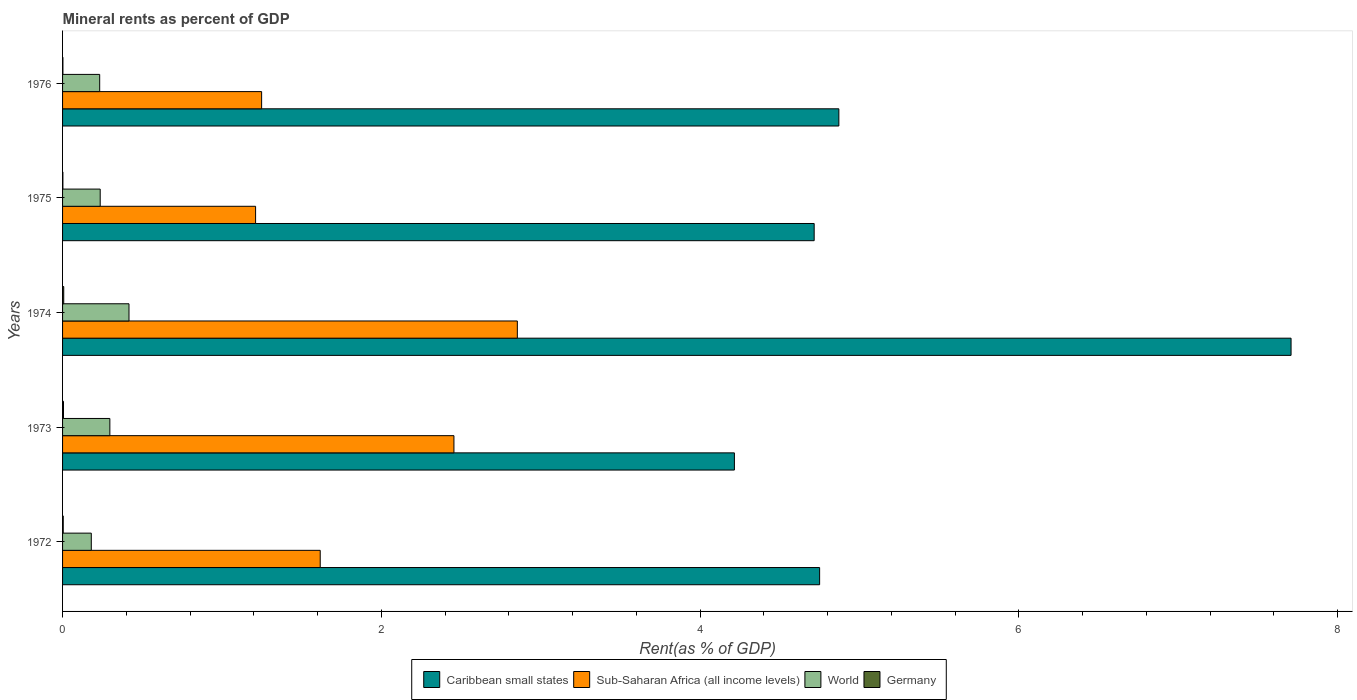How many different coloured bars are there?
Your answer should be compact. 4. How many groups of bars are there?
Your answer should be very brief. 5. Are the number of bars per tick equal to the number of legend labels?
Provide a succinct answer. Yes. Are the number of bars on each tick of the Y-axis equal?
Your answer should be compact. Yes. How many bars are there on the 2nd tick from the bottom?
Keep it short and to the point. 4. What is the label of the 4th group of bars from the top?
Keep it short and to the point. 1973. What is the mineral rent in Germany in 1973?
Ensure brevity in your answer.  0.01. Across all years, what is the maximum mineral rent in Sub-Saharan Africa (all income levels)?
Keep it short and to the point. 2.85. Across all years, what is the minimum mineral rent in Caribbean small states?
Give a very brief answer. 4.22. In which year was the mineral rent in World maximum?
Your response must be concise. 1974. In which year was the mineral rent in Sub-Saharan Africa (all income levels) minimum?
Your answer should be very brief. 1975. What is the total mineral rent in World in the graph?
Give a very brief answer. 1.36. What is the difference between the mineral rent in Caribbean small states in 1972 and that in 1975?
Provide a succinct answer. 0.03. What is the difference between the mineral rent in Germany in 1973 and the mineral rent in Caribbean small states in 1974?
Your answer should be compact. -7.7. What is the average mineral rent in World per year?
Your answer should be compact. 0.27. In the year 1972, what is the difference between the mineral rent in World and mineral rent in Caribbean small states?
Provide a short and direct response. -4.57. In how many years, is the mineral rent in Caribbean small states greater than 2 %?
Provide a short and direct response. 5. What is the ratio of the mineral rent in Germany in 1974 to that in 1975?
Provide a succinct answer. 3.67. Is the mineral rent in Germany in 1974 less than that in 1975?
Give a very brief answer. No. Is the difference between the mineral rent in World in 1972 and 1976 greater than the difference between the mineral rent in Caribbean small states in 1972 and 1976?
Provide a succinct answer. Yes. What is the difference between the highest and the second highest mineral rent in World?
Provide a succinct answer. 0.12. What is the difference between the highest and the lowest mineral rent in Germany?
Offer a terse response. 0.01. Is it the case that in every year, the sum of the mineral rent in Sub-Saharan Africa (all income levels) and mineral rent in World is greater than the sum of mineral rent in Germany and mineral rent in Caribbean small states?
Make the answer very short. No. Are all the bars in the graph horizontal?
Offer a terse response. Yes. How many years are there in the graph?
Your response must be concise. 5. What is the difference between two consecutive major ticks on the X-axis?
Keep it short and to the point. 2. Does the graph contain grids?
Keep it short and to the point. No. How many legend labels are there?
Your answer should be very brief. 4. What is the title of the graph?
Offer a terse response. Mineral rents as percent of GDP. Does "Low income" appear as one of the legend labels in the graph?
Ensure brevity in your answer.  No. What is the label or title of the X-axis?
Provide a short and direct response. Rent(as % of GDP). What is the label or title of the Y-axis?
Give a very brief answer. Years. What is the Rent(as % of GDP) of Caribbean small states in 1972?
Your response must be concise. 4.75. What is the Rent(as % of GDP) in Sub-Saharan Africa (all income levels) in 1972?
Make the answer very short. 1.62. What is the Rent(as % of GDP) in World in 1972?
Keep it short and to the point. 0.18. What is the Rent(as % of GDP) in Germany in 1972?
Your answer should be compact. 0. What is the Rent(as % of GDP) in Caribbean small states in 1973?
Give a very brief answer. 4.22. What is the Rent(as % of GDP) of Sub-Saharan Africa (all income levels) in 1973?
Offer a very short reply. 2.46. What is the Rent(as % of GDP) in World in 1973?
Ensure brevity in your answer.  0.3. What is the Rent(as % of GDP) of Germany in 1973?
Give a very brief answer. 0.01. What is the Rent(as % of GDP) of Caribbean small states in 1974?
Offer a very short reply. 7.71. What is the Rent(as % of GDP) of Sub-Saharan Africa (all income levels) in 1974?
Provide a short and direct response. 2.85. What is the Rent(as % of GDP) of World in 1974?
Keep it short and to the point. 0.42. What is the Rent(as % of GDP) in Germany in 1974?
Make the answer very short. 0.01. What is the Rent(as % of GDP) of Caribbean small states in 1975?
Your response must be concise. 4.72. What is the Rent(as % of GDP) in Sub-Saharan Africa (all income levels) in 1975?
Provide a short and direct response. 1.21. What is the Rent(as % of GDP) in World in 1975?
Your answer should be compact. 0.24. What is the Rent(as % of GDP) in Germany in 1975?
Offer a very short reply. 0. What is the Rent(as % of GDP) in Caribbean small states in 1976?
Give a very brief answer. 4.87. What is the Rent(as % of GDP) of Sub-Saharan Africa (all income levels) in 1976?
Your response must be concise. 1.25. What is the Rent(as % of GDP) of World in 1976?
Provide a succinct answer. 0.23. What is the Rent(as % of GDP) in Germany in 1976?
Ensure brevity in your answer.  0. Across all years, what is the maximum Rent(as % of GDP) of Caribbean small states?
Your answer should be compact. 7.71. Across all years, what is the maximum Rent(as % of GDP) of Sub-Saharan Africa (all income levels)?
Your answer should be compact. 2.85. Across all years, what is the maximum Rent(as % of GDP) of World?
Keep it short and to the point. 0.42. Across all years, what is the maximum Rent(as % of GDP) of Germany?
Your answer should be compact. 0.01. Across all years, what is the minimum Rent(as % of GDP) in Caribbean small states?
Ensure brevity in your answer.  4.22. Across all years, what is the minimum Rent(as % of GDP) in Sub-Saharan Africa (all income levels)?
Make the answer very short. 1.21. Across all years, what is the minimum Rent(as % of GDP) in World?
Offer a terse response. 0.18. Across all years, what is the minimum Rent(as % of GDP) of Germany?
Provide a short and direct response. 0. What is the total Rent(as % of GDP) of Caribbean small states in the graph?
Your answer should be very brief. 26.26. What is the total Rent(as % of GDP) of Sub-Saharan Africa (all income levels) in the graph?
Your answer should be very brief. 9.39. What is the total Rent(as % of GDP) of World in the graph?
Offer a very short reply. 1.36. What is the total Rent(as % of GDP) of Germany in the graph?
Offer a terse response. 0.02. What is the difference between the Rent(as % of GDP) in Caribbean small states in 1972 and that in 1973?
Offer a very short reply. 0.53. What is the difference between the Rent(as % of GDP) in Sub-Saharan Africa (all income levels) in 1972 and that in 1973?
Give a very brief answer. -0.84. What is the difference between the Rent(as % of GDP) of World in 1972 and that in 1973?
Ensure brevity in your answer.  -0.12. What is the difference between the Rent(as % of GDP) in Germany in 1972 and that in 1973?
Your response must be concise. -0. What is the difference between the Rent(as % of GDP) of Caribbean small states in 1972 and that in 1974?
Keep it short and to the point. -2.96. What is the difference between the Rent(as % of GDP) in Sub-Saharan Africa (all income levels) in 1972 and that in 1974?
Your answer should be very brief. -1.24. What is the difference between the Rent(as % of GDP) of World in 1972 and that in 1974?
Ensure brevity in your answer.  -0.24. What is the difference between the Rent(as % of GDP) of Germany in 1972 and that in 1974?
Offer a very short reply. -0. What is the difference between the Rent(as % of GDP) in Caribbean small states in 1972 and that in 1975?
Offer a very short reply. 0.03. What is the difference between the Rent(as % of GDP) of Sub-Saharan Africa (all income levels) in 1972 and that in 1975?
Your answer should be compact. 0.41. What is the difference between the Rent(as % of GDP) in World in 1972 and that in 1975?
Offer a terse response. -0.06. What is the difference between the Rent(as % of GDP) of Germany in 1972 and that in 1975?
Your answer should be compact. 0. What is the difference between the Rent(as % of GDP) of Caribbean small states in 1972 and that in 1976?
Provide a succinct answer. -0.12. What is the difference between the Rent(as % of GDP) of Sub-Saharan Africa (all income levels) in 1972 and that in 1976?
Make the answer very short. 0.37. What is the difference between the Rent(as % of GDP) of World in 1972 and that in 1976?
Your answer should be compact. -0.05. What is the difference between the Rent(as % of GDP) in Germany in 1972 and that in 1976?
Your response must be concise. 0. What is the difference between the Rent(as % of GDP) of Caribbean small states in 1973 and that in 1974?
Offer a very short reply. -3.49. What is the difference between the Rent(as % of GDP) of Sub-Saharan Africa (all income levels) in 1973 and that in 1974?
Your answer should be compact. -0.4. What is the difference between the Rent(as % of GDP) of World in 1973 and that in 1974?
Make the answer very short. -0.12. What is the difference between the Rent(as % of GDP) in Germany in 1973 and that in 1974?
Give a very brief answer. -0. What is the difference between the Rent(as % of GDP) in Caribbean small states in 1973 and that in 1975?
Your answer should be very brief. -0.5. What is the difference between the Rent(as % of GDP) of Sub-Saharan Africa (all income levels) in 1973 and that in 1975?
Your answer should be very brief. 1.24. What is the difference between the Rent(as % of GDP) of World in 1973 and that in 1975?
Provide a short and direct response. 0.06. What is the difference between the Rent(as % of GDP) of Germany in 1973 and that in 1975?
Provide a succinct answer. 0. What is the difference between the Rent(as % of GDP) in Caribbean small states in 1973 and that in 1976?
Your response must be concise. -0.66. What is the difference between the Rent(as % of GDP) of Sub-Saharan Africa (all income levels) in 1973 and that in 1976?
Offer a terse response. 1.21. What is the difference between the Rent(as % of GDP) of World in 1973 and that in 1976?
Give a very brief answer. 0.06. What is the difference between the Rent(as % of GDP) of Germany in 1973 and that in 1976?
Offer a very short reply. 0. What is the difference between the Rent(as % of GDP) of Caribbean small states in 1974 and that in 1975?
Provide a short and direct response. 2.99. What is the difference between the Rent(as % of GDP) in Sub-Saharan Africa (all income levels) in 1974 and that in 1975?
Your answer should be very brief. 1.64. What is the difference between the Rent(as % of GDP) of World in 1974 and that in 1975?
Your answer should be compact. 0.18. What is the difference between the Rent(as % of GDP) of Germany in 1974 and that in 1975?
Ensure brevity in your answer.  0.01. What is the difference between the Rent(as % of GDP) in Caribbean small states in 1974 and that in 1976?
Offer a very short reply. 2.84. What is the difference between the Rent(as % of GDP) of Sub-Saharan Africa (all income levels) in 1974 and that in 1976?
Your answer should be compact. 1.6. What is the difference between the Rent(as % of GDP) in World in 1974 and that in 1976?
Your answer should be very brief. 0.18. What is the difference between the Rent(as % of GDP) of Germany in 1974 and that in 1976?
Your response must be concise. 0.01. What is the difference between the Rent(as % of GDP) in Caribbean small states in 1975 and that in 1976?
Your answer should be compact. -0.15. What is the difference between the Rent(as % of GDP) of Sub-Saharan Africa (all income levels) in 1975 and that in 1976?
Your response must be concise. -0.04. What is the difference between the Rent(as % of GDP) in World in 1975 and that in 1976?
Make the answer very short. 0. What is the difference between the Rent(as % of GDP) of Germany in 1975 and that in 1976?
Provide a short and direct response. -0. What is the difference between the Rent(as % of GDP) in Caribbean small states in 1972 and the Rent(as % of GDP) in Sub-Saharan Africa (all income levels) in 1973?
Provide a succinct answer. 2.29. What is the difference between the Rent(as % of GDP) in Caribbean small states in 1972 and the Rent(as % of GDP) in World in 1973?
Provide a short and direct response. 4.45. What is the difference between the Rent(as % of GDP) of Caribbean small states in 1972 and the Rent(as % of GDP) of Germany in 1973?
Offer a very short reply. 4.74. What is the difference between the Rent(as % of GDP) in Sub-Saharan Africa (all income levels) in 1972 and the Rent(as % of GDP) in World in 1973?
Your answer should be compact. 1.32. What is the difference between the Rent(as % of GDP) of Sub-Saharan Africa (all income levels) in 1972 and the Rent(as % of GDP) of Germany in 1973?
Provide a succinct answer. 1.61. What is the difference between the Rent(as % of GDP) of World in 1972 and the Rent(as % of GDP) of Germany in 1973?
Your answer should be very brief. 0.17. What is the difference between the Rent(as % of GDP) in Caribbean small states in 1972 and the Rent(as % of GDP) in Sub-Saharan Africa (all income levels) in 1974?
Make the answer very short. 1.9. What is the difference between the Rent(as % of GDP) of Caribbean small states in 1972 and the Rent(as % of GDP) of World in 1974?
Ensure brevity in your answer.  4.33. What is the difference between the Rent(as % of GDP) of Caribbean small states in 1972 and the Rent(as % of GDP) of Germany in 1974?
Keep it short and to the point. 4.74. What is the difference between the Rent(as % of GDP) of Sub-Saharan Africa (all income levels) in 1972 and the Rent(as % of GDP) of World in 1974?
Ensure brevity in your answer.  1.2. What is the difference between the Rent(as % of GDP) of Sub-Saharan Africa (all income levels) in 1972 and the Rent(as % of GDP) of Germany in 1974?
Offer a very short reply. 1.61. What is the difference between the Rent(as % of GDP) of World in 1972 and the Rent(as % of GDP) of Germany in 1974?
Offer a terse response. 0.17. What is the difference between the Rent(as % of GDP) in Caribbean small states in 1972 and the Rent(as % of GDP) in Sub-Saharan Africa (all income levels) in 1975?
Ensure brevity in your answer.  3.54. What is the difference between the Rent(as % of GDP) in Caribbean small states in 1972 and the Rent(as % of GDP) in World in 1975?
Ensure brevity in your answer.  4.51. What is the difference between the Rent(as % of GDP) in Caribbean small states in 1972 and the Rent(as % of GDP) in Germany in 1975?
Give a very brief answer. 4.75. What is the difference between the Rent(as % of GDP) of Sub-Saharan Africa (all income levels) in 1972 and the Rent(as % of GDP) of World in 1975?
Give a very brief answer. 1.38. What is the difference between the Rent(as % of GDP) in Sub-Saharan Africa (all income levels) in 1972 and the Rent(as % of GDP) in Germany in 1975?
Provide a succinct answer. 1.61. What is the difference between the Rent(as % of GDP) of World in 1972 and the Rent(as % of GDP) of Germany in 1975?
Give a very brief answer. 0.18. What is the difference between the Rent(as % of GDP) of Caribbean small states in 1972 and the Rent(as % of GDP) of Sub-Saharan Africa (all income levels) in 1976?
Offer a terse response. 3.5. What is the difference between the Rent(as % of GDP) of Caribbean small states in 1972 and the Rent(as % of GDP) of World in 1976?
Your response must be concise. 4.52. What is the difference between the Rent(as % of GDP) in Caribbean small states in 1972 and the Rent(as % of GDP) in Germany in 1976?
Your answer should be compact. 4.75. What is the difference between the Rent(as % of GDP) in Sub-Saharan Africa (all income levels) in 1972 and the Rent(as % of GDP) in World in 1976?
Ensure brevity in your answer.  1.38. What is the difference between the Rent(as % of GDP) in Sub-Saharan Africa (all income levels) in 1972 and the Rent(as % of GDP) in Germany in 1976?
Your response must be concise. 1.61. What is the difference between the Rent(as % of GDP) in World in 1972 and the Rent(as % of GDP) in Germany in 1976?
Provide a succinct answer. 0.18. What is the difference between the Rent(as % of GDP) in Caribbean small states in 1973 and the Rent(as % of GDP) in Sub-Saharan Africa (all income levels) in 1974?
Provide a short and direct response. 1.36. What is the difference between the Rent(as % of GDP) of Caribbean small states in 1973 and the Rent(as % of GDP) of World in 1974?
Make the answer very short. 3.8. What is the difference between the Rent(as % of GDP) of Caribbean small states in 1973 and the Rent(as % of GDP) of Germany in 1974?
Provide a succinct answer. 4.21. What is the difference between the Rent(as % of GDP) of Sub-Saharan Africa (all income levels) in 1973 and the Rent(as % of GDP) of World in 1974?
Offer a very short reply. 2.04. What is the difference between the Rent(as % of GDP) of Sub-Saharan Africa (all income levels) in 1973 and the Rent(as % of GDP) of Germany in 1974?
Make the answer very short. 2.45. What is the difference between the Rent(as % of GDP) in World in 1973 and the Rent(as % of GDP) in Germany in 1974?
Your answer should be very brief. 0.29. What is the difference between the Rent(as % of GDP) in Caribbean small states in 1973 and the Rent(as % of GDP) in Sub-Saharan Africa (all income levels) in 1975?
Your answer should be very brief. 3. What is the difference between the Rent(as % of GDP) of Caribbean small states in 1973 and the Rent(as % of GDP) of World in 1975?
Ensure brevity in your answer.  3.98. What is the difference between the Rent(as % of GDP) in Caribbean small states in 1973 and the Rent(as % of GDP) in Germany in 1975?
Give a very brief answer. 4.21. What is the difference between the Rent(as % of GDP) in Sub-Saharan Africa (all income levels) in 1973 and the Rent(as % of GDP) in World in 1975?
Offer a very short reply. 2.22. What is the difference between the Rent(as % of GDP) in Sub-Saharan Africa (all income levels) in 1973 and the Rent(as % of GDP) in Germany in 1975?
Make the answer very short. 2.45. What is the difference between the Rent(as % of GDP) in World in 1973 and the Rent(as % of GDP) in Germany in 1975?
Make the answer very short. 0.29. What is the difference between the Rent(as % of GDP) of Caribbean small states in 1973 and the Rent(as % of GDP) of Sub-Saharan Africa (all income levels) in 1976?
Make the answer very short. 2.97. What is the difference between the Rent(as % of GDP) of Caribbean small states in 1973 and the Rent(as % of GDP) of World in 1976?
Offer a very short reply. 3.98. What is the difference between the Rent(as % of GDP) in Caribbean small states in 1973 and the Rent(as % of GDP) in Germany in 1976?
Give a very brief answer. 4.21. What is the difference between the Rent(as % of GDP) of Sub-Saharan Africa (all income levels) in 1973 and the Rent(as % of GDP) of World in 1976?
Make the answer very short. 2.22. What is the difference between the Rent(as % of GDP) of Sub-Saharan Africa (all income levels) in 1973 and the Rent(as % of GDP) of Germany in 1976?
Offer a very short reply. 2.45. What is the difference between the Rent(as % of GDP) of World in 1973 and the Rent(as % of GDP) of Germany in 1976?
Offer a very short reply. 0.29. What is the difference between the Rent(as % of GDP) in Caribbean small states in 1974 and the Rent(as % of GDP) in Sub-Saharan Africa (all income levels) in 1975?
Your answer should be very brief. 6.5. What is the difference between the Rent(as % of GDP) of Caribbean small states in 1974 and the Rent(as % of GDP) of World in 1975?
Your answer should be very brief. 7.47. What is the difference between the Rent(as % of GDP) of Caribbean small states in 1974 and the Rent(as % of GDP) of Germany in 1975?
Your answer should be compact. 7.71. What is the difference between the Rent(as % of GDP) of Sub-Saharan Africa (all income levels) in 1974 and the Rent(as % of GDP) of World in 1975?
Provide a succinct answer. 2.62. What is the difference between the Rent(as % of GDP) in Sub-Saharan Africa (all income levels) in 1974 and the Rent(as % of GDP) in Germany in 1975?
Make the answer very short. 2.85. What is the difference between the Rent(as % of GDP) in World in 1974 and the Rent(as % of GDP) in Germany in 1975?
Make the answer very short. 0.41. What is the difference between the Rent(as % of GDP) of Caribbean small states in 1974 and the Rent(as % of GDP) of Sub-Saharan Africa (all income levels) in 1976?
Your response must be concise. 6.46. What is the difference between the Rent(as % of GDP) of Caribbean small states in 1974 and the Rent(as % of GDP) of World in 1976?
Your response must be concise. 7.48. What is the difference between the Rent(as % of GDP) in Caribbean small states in 1974 and the Rent(as % of GDP) in Germany in 1976?
Your answer should be very brief. 7.71. What is the difference between the Rent(as % of GDP) of Sub-Saharan Africa (all income levels) in 1974 and the Rent(as % of GDP) of World in 1976?
Give a very brief answer. 2.62. What is the difference between the Rent(as % of GDP) of Sub-Saharan Africa (all income levels) in 1974 and the Rent(as % of GDP) of Germany in 1976?
Give a very brief answer. 2.85. What is the difference between the Rent(as % of GDP) of World in 1974 and the Rent(as % of GDP) of Germany in 1976?
Your answer should be compact. 0.41. What is the difference between the Rent(as % of GDP) of Caribbean small states in 1975 and the Rent(as % of GDP) of Sub-Saharan Africa (all income levels) in 1976?
Provide a succinct answer. 3.47. What is the difference between the Rent(as % of GDP) in Caribbean small states in 1975 and the Rent(as % of GDP) in World in 1976?
Make the answer very short. 4.48. What is the difference between the Rent(as % of GDP) in Caribbean small states in 1975 and the Rent(as % of GDP) in Germany in 1976?
Offer a very short reply. 4.71. What is the difference between the Rent(as % of GDP) of Sub-Saharan Africa (all income levels) in 1975 and the Rent(as % of GDP) of World in 1976?
Your answer should be compact. 0.98. What is the difference between the Rent(as % of GDP) of Sub-Saharan Africa (all income levels) in 1975 and the Rent(as % of GDP) of Germany in 1976?
Offer a very short reply. 1.21. What is the difference between the Rent(as % of GDP) of World in 1975 and the Rent(as % of GDP) of Germany in 1976?
Provide a short and direct response. 0.23. What is the average Rent(as % of GDP) in Caribbean small states per year?
Make the answer very short. 5.25. What is the average Rent(as % of GDP) in Sub-Saharan Africa (all income levels) per year?
Your answer should be compact. 1.88. What is the average Rent(as % of GDP) of World per year?
Your answer should be compact. 0.27. What is the average Rent(as % of GDP) in Germany per year?
Keep it short and to the point. 0. In the year 1972, what is the difference between the Rent(as % of GDP) in Caribbean small states and Rent(as % of GDP) in Sub-Saharan Africa (all income levels)?
Provide a succinct answer. 3.13. In the year 1972, what is the difference between the Rent(as % of GDP) in Caribbean small states and Rent(as % of GDP) in World?
Your answer should be compact. 4.57. In the year 1972, what is the difference between the Rent(as % of GDP) of Caribbean small states and Rent(as % of GDP) of Germany?
Your answer should be compact. 4.75. In the year 1972, what is the difference between the Rent(as % of GDP) of Sub-Saharan Africa (all income levels) and Rent(as % of GDP) of World?
Provide a short and direct response. 1.44. In the year 1972, what is the difference between the Rent(as % of GDP) in Sub-Saharan Africa (all income levels) and Rent(as % of GDP) in Germany?
Give a very brief answer. 1.61. In the year 1972, what is the difference between the Rent(as % of GDP) of World and Rent(as % of GDP) of Germany?
Give a very brief answer. 0.18. In the year 1973, what is the difference between the Rent(as % of GDP) in Caribbean small states and Rent(as % of GDP) in Sub-Saharan Africa (all income levels)?
Provide a short and direct response. 1.76. In the year 1973, what is the difference between the Rent(as % of GDP) in Caribbean small states and Rent(as % of GDP) in World?
Your response must be concise. 3.92. In the year 1973, what is the difference between the Rent(as % of GDP) in Caribbean small states and Rent(as % of GDP) in Germany?
Provide a short and direct response. 4.21. In the year 1973, what is the difference between the Rent(as % of GDP) in Sub-Saharan Africa (all income levels) and Rent(as % of GDP) in World?
Your answer should be very brief. 2.16. In the year 1973, what is the difference between the Rent(as % of GDP) of Sub-Saharan Africa (all income levels) and Rent(as % of GDP) of Germany?
Keep it short and to the point. 2.45. In the year 1973, what is the difference between the Rent(as % of GDP) of World and Rent(as % of GDP) of Germany?
Offer a very short reply. 0.29. In the year 1974, what is the difference between the Rent(as % of GDP) of Caribbean small states and Rent(as % of GDP) of Sub-Saharan Africa (all income levels)?
Make the answer very short. 4.86. In the year 1974, what is the difference between the Rent(as % of GDP) in Caribbean small states and Rent(as % of GDP) in World?
Provide a short and direct response. 7.29. In the year 1974, what is the difference between the Rent(as % of GDP) in Caribbean small states and Rent(as % of GDP) in Germany?
Provide a short and direct response. 7.7. In the year 1974, what is the difference between the Rent(as % of GDP) in Sub-Saharan Africa (all income levels) and Rent(as % of GDP) in World?
Provide a short and direct response. 2.44. In the year 1974, what is the difference between the Rent(as % of GDP) in Sub-Saharan Africa (all income levels) and Rent(as % of GDP) in Germany?
Your answer should be compact. 2.85. In the year 1974, what is the difference between the Rent(as % of GDP) of World and Rent(as % of GDP) of Germany?
Provide a succinct answer. 0.41. In the year 1975, what is the difference between the Rent(as % of GDP) in Caribbean small states and Rent(as % of GDP) in Sub-Saharan Africa (all income levels)?
Your answer should be compact. 3.5. In the year 1975, what is the difference between the Rent(as % of GDP) of Caribbean small states and Rent(as % of GDP) of World?
Your response must be concise. 4.48. In the year 1975, what is the difference between the Rent(as % of GDP) in Caribbean small states and Rent(as % of GDP) in Germany?
Provide a short and direct response. 4.71. In the year 1975, what is the difference between the Rent(as % of GDP) of Sub-Saharan Africa (all income levels) and Rent(as % of GDP) of World?
Keep it short and to the point. 0.98. In the year 1975, what is the difference between the Rent(as % of GDP) of Sub-Saharan Africa (all income levels) and Rent(as % of GDP) of Germany?
Your response must be concise. 1.21. In the year 1975, what is the difference between the Rent(as % of GDP) of World and Rent(as % of GDP) of Germany?
Offer a very short reply. 0.23. In the year 1976, what is the difference between the Rent(as % of GDP) in Caribbean small states and Rent(as % of GDP) in Sub-Saharan Africa (all income levels)?
Provide a short and direct response. 3.62. In the year 1976, what is the difference between the Rent(as % of GDP) in Caribbean small states and Rent(as % of GDP) in World?
Give a very brief answer. 4.64. In the year 1976, what is the difference between the Rent(as % of GDP) of Caribbean small states and Rent(as % of GDP) of Germany?
Offer a terse response. 4.87. In the year 1976, what is the difference between the Rent(as % of GDP) in Sub-Saharan Africa (all income levels) and Rent(as % of GDP) in World?
Your response must be concise. 1.02. In the year 1976, what is the difference between the Rent(as % of GDP) in Sub-Saharan Africa (all income levels) and Rent(as % of GDP) in Germany?
Provide a succinct answer. 1.25. In the year 1976, what is the difference between the Rent(as % of GDP) of World and Rent(as % of GDP) of Germany?
Your answer should be very brief. 0.23. What is the ratio of the Rent(as % of GDP) in Caribbean small states in 1972 to that in 1973?
Offer a very short reply. 1.13. What is the ratio of the Rent(as % of GDP) of Sub-Saharan Africa (all income levels) in 1972 to that in 1973?
Give a very brief answer. 0.66. What is the ratio of the Rent(as % of GDP) in World in 1972 to that in 1973?
Your response must be concise. 0.61. What is the ratio of the Rent(as % of GDP) in Germany in 1972 to that in 1973?
Give a very brief answer. 0.72. What is the ratio of the Rent(as % of GDP) of Caribbean small states in 1972 to that in 1974?
Make the answer very short. 0.62. What is the ratio of the Rent(as % of GDP) in Sub-Saharan Africa (all income levels) in 1972 to that in 1974?
Offer a very short reply. 0.57. What is the ratio of the Rent(as % of GDP) in World in 1972 to that in 1974?
Offer a terse response. 0.43. What is the ratio of the Rent(as % of GDP) in Germany in 1972 to that in 1974?
Provide a succinct answer. 0.57. What is the ratio of the Rent(as % of GDP) of Caribbean small states in 1972 to that in 1975?
Give a very brief answer. 1.01. What is the ratio of the Rent(as % of GDP) of Sub-Saharan Africa (all income levels) in 1972 to that in 1975?
Give a very brief answer. 1.33. What is the ratio of the Rent(as % of GDP) in World in 1972 to that in 1975?
Make the answer very short. 0.76. What is the ratio of the Rent(as % of GDP) of Germany in 1972 to that in 1975?
Ensure brevity in your answer.  2.09. What is the ratio of the Rent(as % of GDP) in Caribbean small states in 1972 to that in 1976?
Make the answer very short. 0.98. What is the ratio of the Rent(as % of GDP) of Sub-Saharan Africa (all income levels) in 1972 to that in 1976?
Your response must be concise. 1.29. What is the ratio of the Rent(as % of GDP) in World in 1972 to that in 1976?
Give a very brief answer. 0.77. What is the ratio of the Rent(as % of GDP) of Germany in 1972 to that in 1976?
Offer a terse response. 1.85. What is the ratio of the Rent(as % of GDP) of Caribbean small states in 1973 to that in 1974?
Ensure brevity in your answer.  0.55. What is the ratio of the Rent(as % of GDP) in Sub-Saharan Africa (all income levels) in 1973 to that in 1974?
Your answer should be very brief. 0.86. What is the ratio of the Rent(as % of GDP) of World in 1973 to that in 1974?
Your answer should be very brief. 0.71. What is the ratio of the Rent(as % of GDP) of Germany in 1973 to that in 1974?
Keep it short and to the point. 0.79. What is the ratio of the Rent(as % of GDP) of Caribbean small states in 1973 to that in 1975?
Ensure brevity in your answer.  0.89. What is the ratio of the Rent(as % of GDP) of Sub-Saharan Africa (all income levels) in 1973 to that in 1975?
Your response must be concise. 2.03. What is the ratio of the Rent(as % of GDP) in World in 1973 to that in 1975?
Provide a succinct answer. 1.26. What is the ratio of the Rent(as % of GDP) of Germany in 1973 to that in 1975?
Your response must be concise. 2.9. What is the ratio of the Rent(as % of GDP) in Caribbean small states in 1973 to that in 1976?
Provide a succinct answer. 0.87. What is the ratio of the Rent(as % of GDP) of Sub-Saharan Africa (all income levels) in 1973 to that in 1976?
Your response must be concise. 1.97. What is the ratio of the Rent(as % of GDP) in World in 1973 to that in 1976?
Ensure brevity in your answer.  1.27. What is the ratio of the Rent(as % of GDP) in Germany in 1973 to that in 1976?
Your answer should be compact. 2.57. What is the ratio of the Rent(as % of GDP) in Caribbean small states in 1974 to that in 1975?
Give a very brief answer. 1.63. What is the ratio of the Rent(as % of GDP) in Sub-Saharan Africa (all income levels) in 1974 to that in 1975?
Your answer should be very brief. 2.36. What is the ratio of the Rent(as % of GDP) in World in 1974 to that in 1975?
Ensure brevity in your answer.  1.77. What is the ratio of the Rent(as % of GDP) of Germany in 1974 to that in 1975?
Your answer should be compact. 3.67. What is the ratio of the Rent(as % of GDP) in Caribbean small states in 1974 to that in 1976?
Your answer should be very brief. 1.58. What is the ratio of the Rent(as % of GDP) of Sub-Saharan Africa (all income levels) in 1974 to that in 1976?
Keep it short and to the point. 2.28. What is the ratio of the Rent(as % of GDP) in World in 1974 to that in 1976?
Ensure brevity in your answer.  1.79. What is the ratio of the Rent(as % of GDP) in Germany in 1974 to that in 1976?
Keep it short and to the point. 3.25. What is the ratio of the Rent(as % of GDP) of Caribbean small states in 1975 to that in 1976?
Offer a very short reply. 0.97. What is the ratio of the Rent(as % of GDP) of Sub-Saharan Africa (all income levels) in 1975 to that in 1976?
Offer a very short reply. 0.97. What is the ratio of the Rent(as % of GDP) of World in 1975 to that in 1976?
Ensure brevity in your answer.  1.01. What is the ratio of the Rent(as % of GDP) in Germany in 1975 to that in 1976?
Provide a succinct answer. 0.88. What is the difference between the highest and the second highest Rent(as % of GDP) of Caribbean small states?
Offer a very short reply. 2.84. What is the difference between the highest and the second highest Rent(as % of GDP) of Sub-Saharan Africa (all income levels)?
Offer a terse response. 0.4. What is the difference between the highest and the second highest Rent(as % of GDP) of World?
Your response must be concise. 0.12. What is the difference between the highest and the second highest Rent(as % of GDP) of Germany?
Provide a succinct answer. 0. What is the difference between the highest and the lowest Rent(as % of GDP) in Caribbean small states?
Provide a succinct answer. 3.49. What is the difference between the highest and the lowest Rent(as % of GDP) of Sub-Saharan Africa (all income levels)?
Offer a terse response. 1.64. What is the difference between the highest and the lowest Rent(as % of GDP) in World?
Ensure brevity in your answer.  0.24. What is the difference between the highest and the lowest Rent(as % of GDP) in Germany?
Provide a short and direct response. 0.01. 